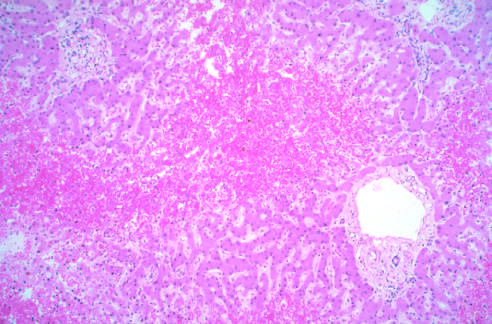re aortic elastic layers not easily seen?
Answer the question using a single word or phrase. No 